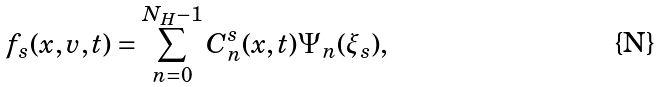Convert formula to latex. <formula><loc_0><loc_0><loc_500><loc_500>f _ { s } ( x , v , t ) = \sum _ { n = 0 } ^ { N _ { H } - 1 } C ^ { s } _ { n } ( x , t ) \Psi _ { n } ( \xi _ { s } ) ,</formula> 